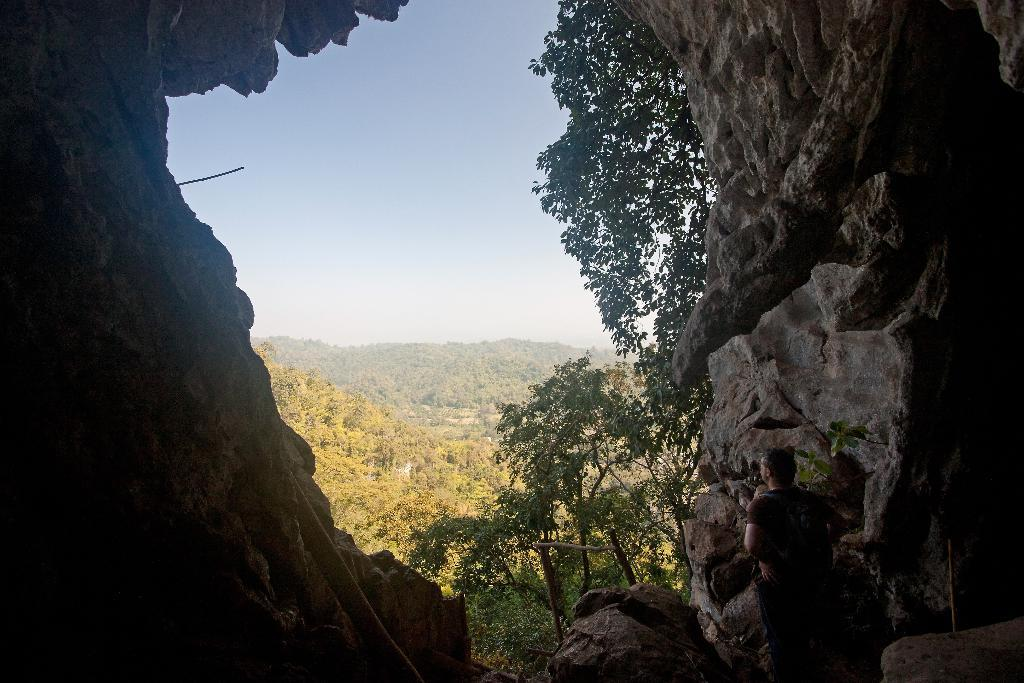What type of natural formation is present in the image? There is a cave in the image. Can you describe the person in the image? There is a person in the image. What type of vegetation can be seen in the image? There are trees in the image. What type of landscape feature is present in the image? There are hills in the image. What is visible in the sky in the image? The sky is visible in the image. How many bears can be seen begging for food in the image? There are no bears or begging in the image; it features a cave, a person, trees, hills, and a visible sky. What type of ornament is hanging from the trees in the image? There are no ornaments hanging from the trees in the image; it only features trees, a cave, a person, hills, and a visible sky. 